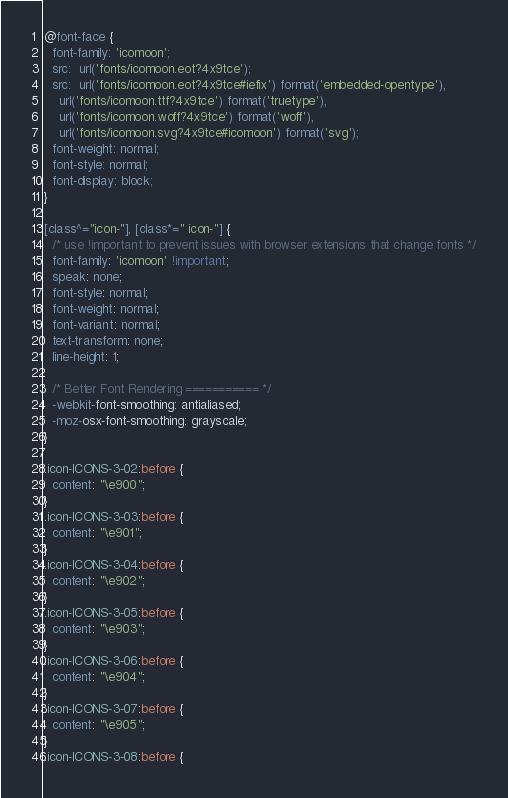Convert code to text. <code><loc_0><loc_0><loc_500><loc_500><_CSS_>@font-face {
  font-family: 'icomoon';
  src:  url('fonts/icomoon.eot?4x9tce');
  src:  url('fonts/icomoon.eot?4x9tce#iefix') format('embedded-opentype'),
    url('fonts/icomoon.ttf?4x9tce') format('truetype'),
    url('fonts/icomoon.woff?4x9tce') format('woff'),
    url('fonts/icomoon.svg?4x9tce#icomoon') format('svg');
  font-weight: normal;
  font-style: normal;
  font-display: block;
}

[class^="icon-"], [class*=" icon-"] {
  /* use !important to prevent issues with browser extensions that change fonts */
  font-family: 'icomoon' !important;
  speak: none;
  font-style: normal;
  font-weight: normal;
  font-variant: normal;
  text-transform: none;
  line-height: 1;

  /* Better Font Rendering =========== */
  -webkit-font-smoothing: antialiased;
  -moz-osx-font-smoothing: grayscale;
}

.icon-ICONS-3-02:before {
  content: "\e900";
}
.icon-ICONS-3-03:before {
  content: "\e901";
}
.icon-ICONS-3-04:before {
  content: "\e902";
}
.icon-ICONS-3-05:before {
  content: "\e903";
}
.icon-ICONS-3-06:before {
  content: "\e904";
}
.icon-ICONS-3-07:before {
  content: "\e905";
}
.icon-ICONS-3-08:before {</code> 